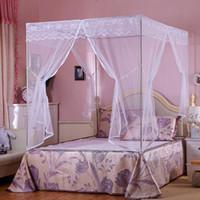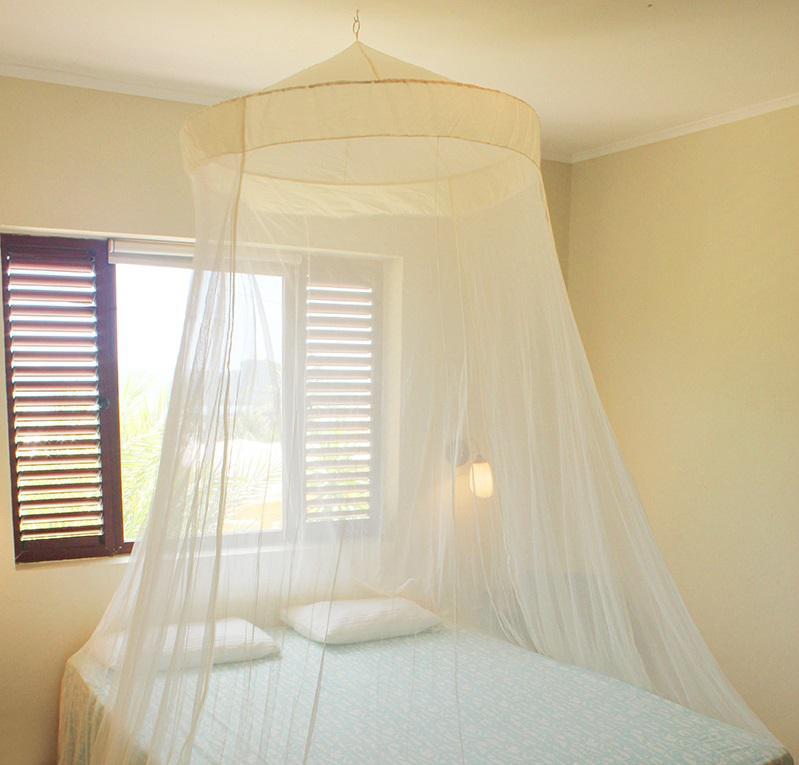The first image is the image on the left, the second image is the image on the right. Examine the images to the left and right. Is the description "One image shows a ceiling-suspended gauzy canopy over a bed." accurate? Answer yes or no. Yes. 